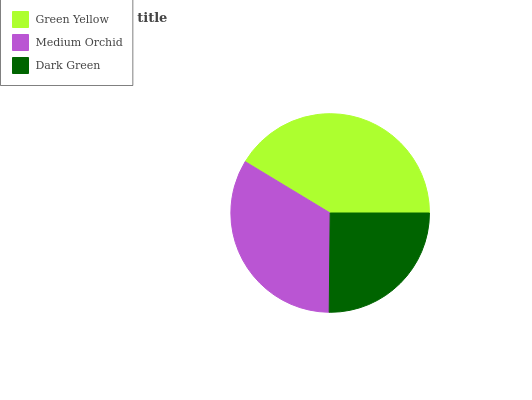Is Dark Green the minimum?
Answer yes or no. Yes. Is Green Yellow the maximum?
Answer yes or no. Yes. Is Medium Orchid the minimum?
Answer yes or no. No. Is Medium Orchid the maximum?
Answer yes or no. No. Is Green Yellow greater than Medium Orchid?
Answer yes or no. Yes. Is Medium Orchid less than Green Yellow?
Answer yes or no. Yes. Is Medium Orchid greater than Green Yellow?
Answer yes or no. No. Is Green Yellow less than Medium Orchid?
Answer yes or no. No. Is Medium Orchid the high median?
Answer yes or no. Yes. Is Medium Orchid the low median?
Answer yes or no. Yes. Is Green Yellow the high median?
Answer yes or no. No. Is Green Yellow the low median?
Answer yes or no. No. 